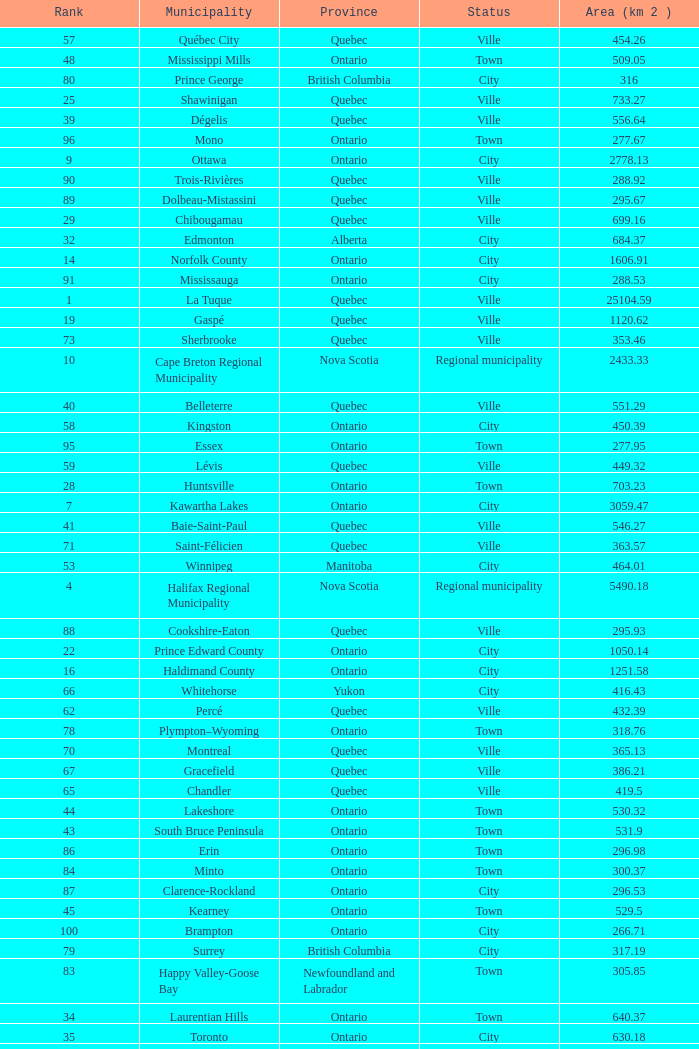What's the total of Rank that has an Area (KM 2) of 1050.14? 22.0. 